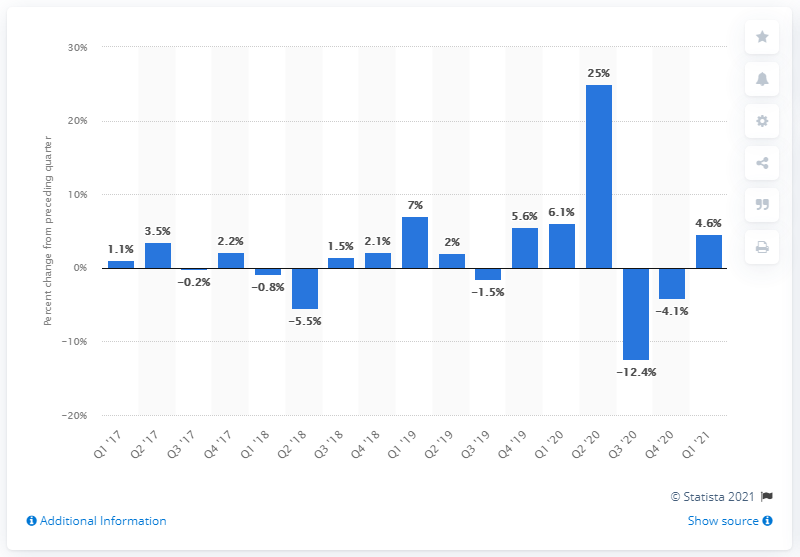Specify some key components in this picture. In the first quarter of 2021, the real hourly compensation in the manufacturing sector increased by 4.6%. 